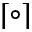<formula> <loc_0><loc_0><loc_500><loc_500>\lceil \circ \rceil</formula> 